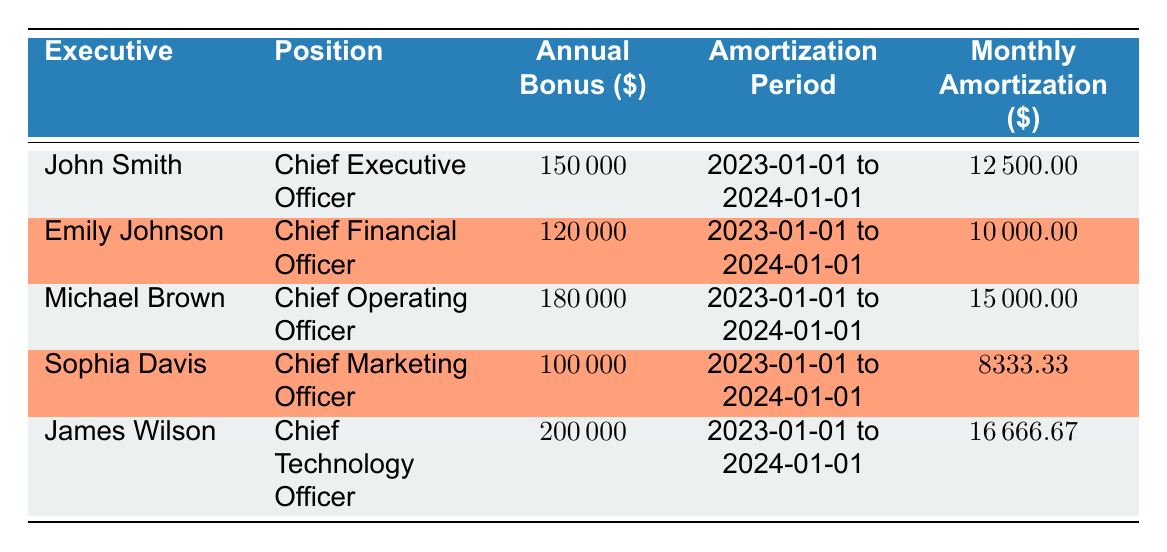What is the annual bonus for John Smith? The table shows that John Smith has an annual bonus of 150000.
Answer: 150000 What is the position of Emily Johnson? According to the table, Emily Johnson is the Chief Financial Officer.
Answer: Chief Financial Officer How much is the monthly amortization for the Chief Technology Officer? The monthly amortization for James Wilson, the Chief Technology Officer, is 16666.67.
Answer: 16666.67 Who has the highest annual bonus among the executives? By looking at the annual bonuses listed, James Wilson has the highest bonus at 200000.
Answer: James Wilson What is the average monthly amortization of all executives? The monthly amortizations are 12500, 10000, 15000, 8333.33, and 16666.67. Adding these gives  12500 + 10000 + 15000 + 8333.33 + 16666.67 = 62500. There are 5 executives, so the average is 62500/5 = 12500.
Answer: 12500 Is Sophia Davis's annual bonus greater than Michael Brown's? Sophia Davis has an annual bonus of 100000 while Michael Brown has an annual bonus of 180000. Since 100000 is less than 180000, the statement is false.
Answer: No If you combined the annual bonuses of the Chief Executive Officer and the Chief Marketing Officer, what would be their total? The annual bonus for John Smith is 150000, and for Sophia Davis, it's 100000. Adding these gives 150000 + 100000 = 250000.
Answer: 250000 Is the amortization period for all executives the same? The amortization period for all executives listed is from 2023-01-01 to 2024-01-01. Therefore, yes, they all share the same period.
Answer: Yes What is the difference between the annual bonuses of the Chief Financial Officer and the Chief Operating Officer? The Chief Financial Officer, Emily Johnson, has an annual bonus of 120000, while the Chief Operating Officer, Michael Brown, has an annual bonus of 180000. The difference is 180000 - 120000 = 60000.
Answer: 60000 